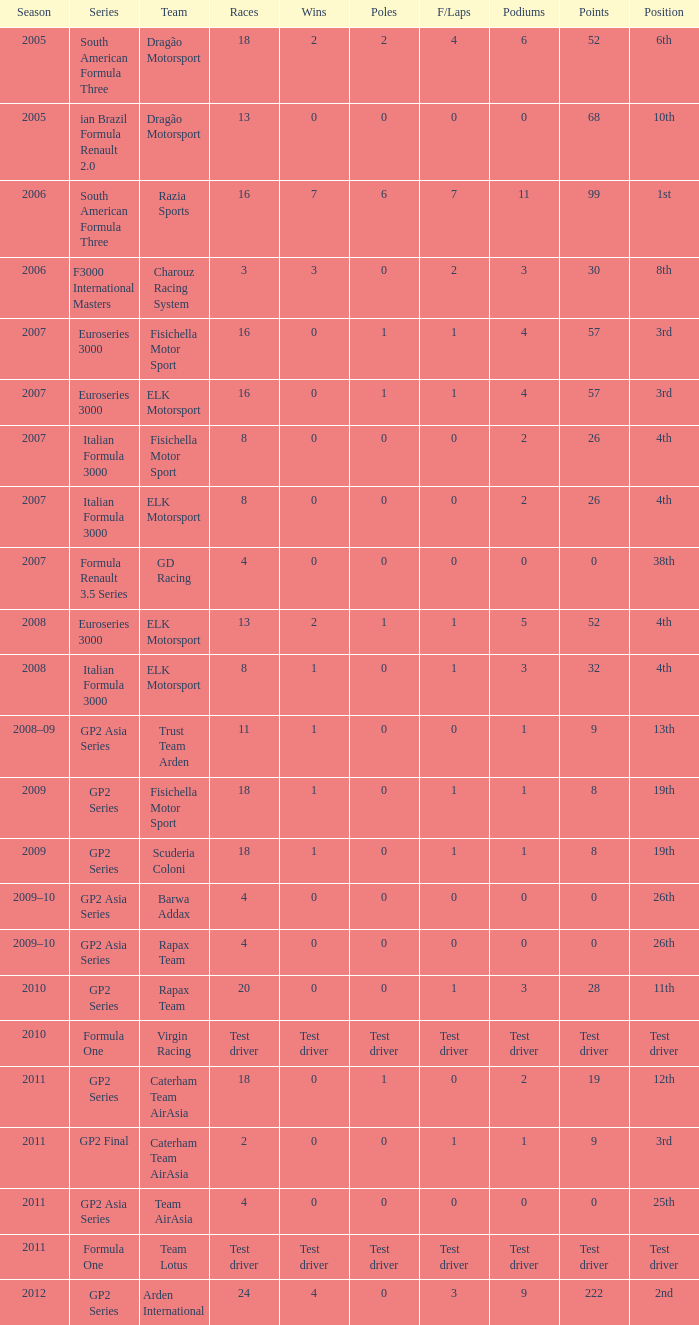What was the f/laps when the triumphs were 0 and the place was 4th? 0, 0. 